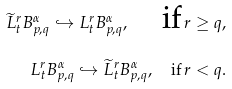Convert formula to latex. <formula><loc_0><loc_0><loc_500><loc_500>\widetilde { L } ^ { r } _ { t } B ^ { \alpha } _ { p , q } \hookrightarrow { L } ^ { r } _ { t } B ^ { \alpha } _ { p , q } , \quad \text {if} \, r \geq q , \\ { L } ^ { r } _ { t } B ^ { \alpha } _ { p , q } \hookrightarrow \widetilde { L } ^ { r } _ { t } B ^ { \alpha } _ { p , q } , \quad \text {if} \, r < q .</formula> 